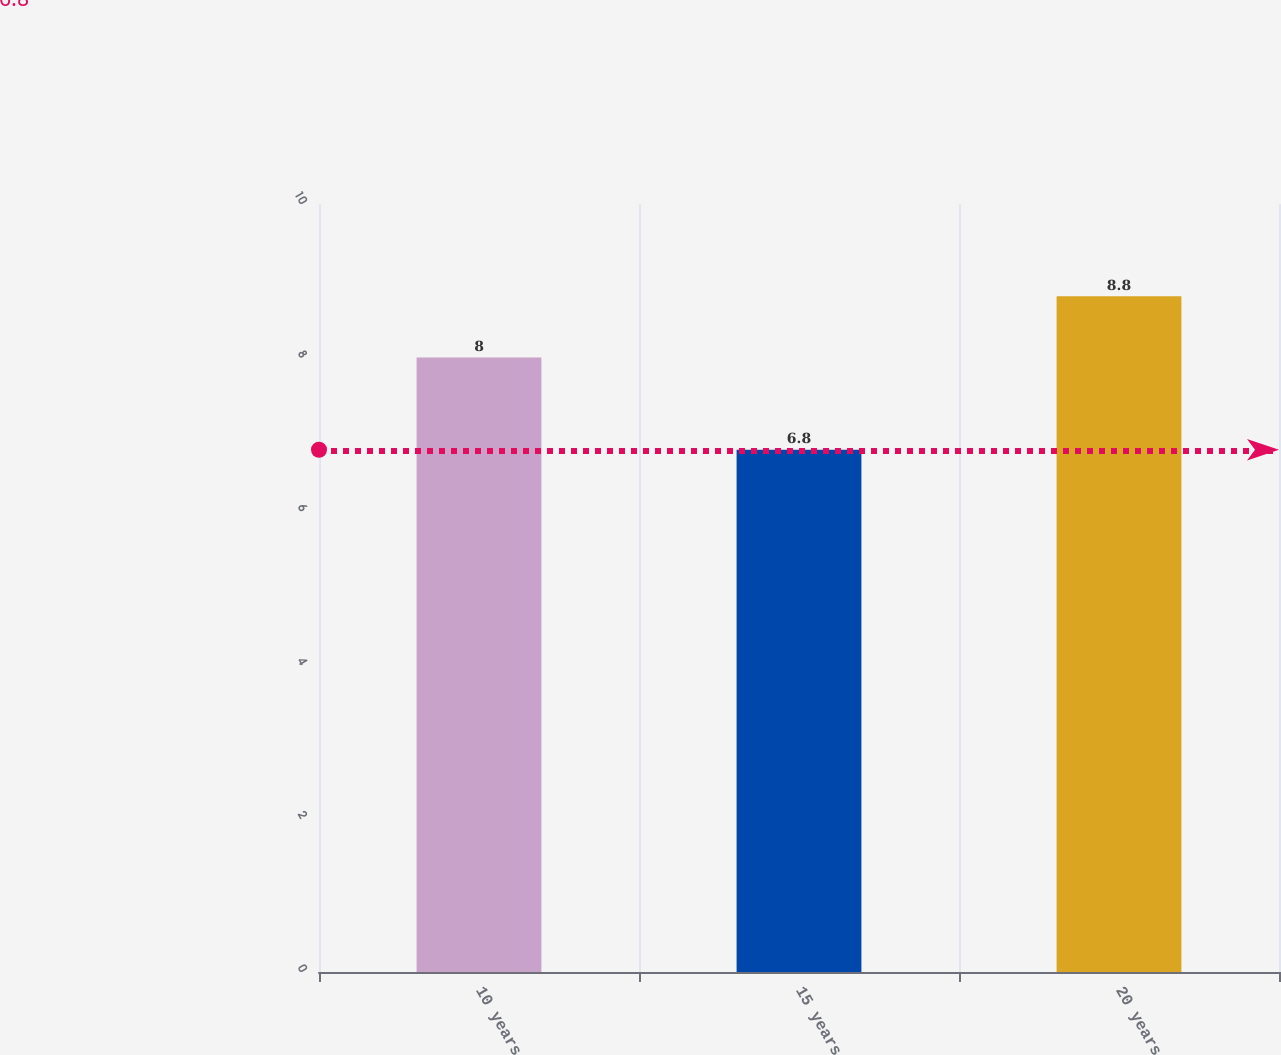Convert chart. <chart><loc_0><loc_0><loc_500><loc_500><bar_chart><fcel>10 years<fcel>15 years<fcel>20 years<nl><fcel>8<fcel>6.8<fcel>8.8<nl></chart> 